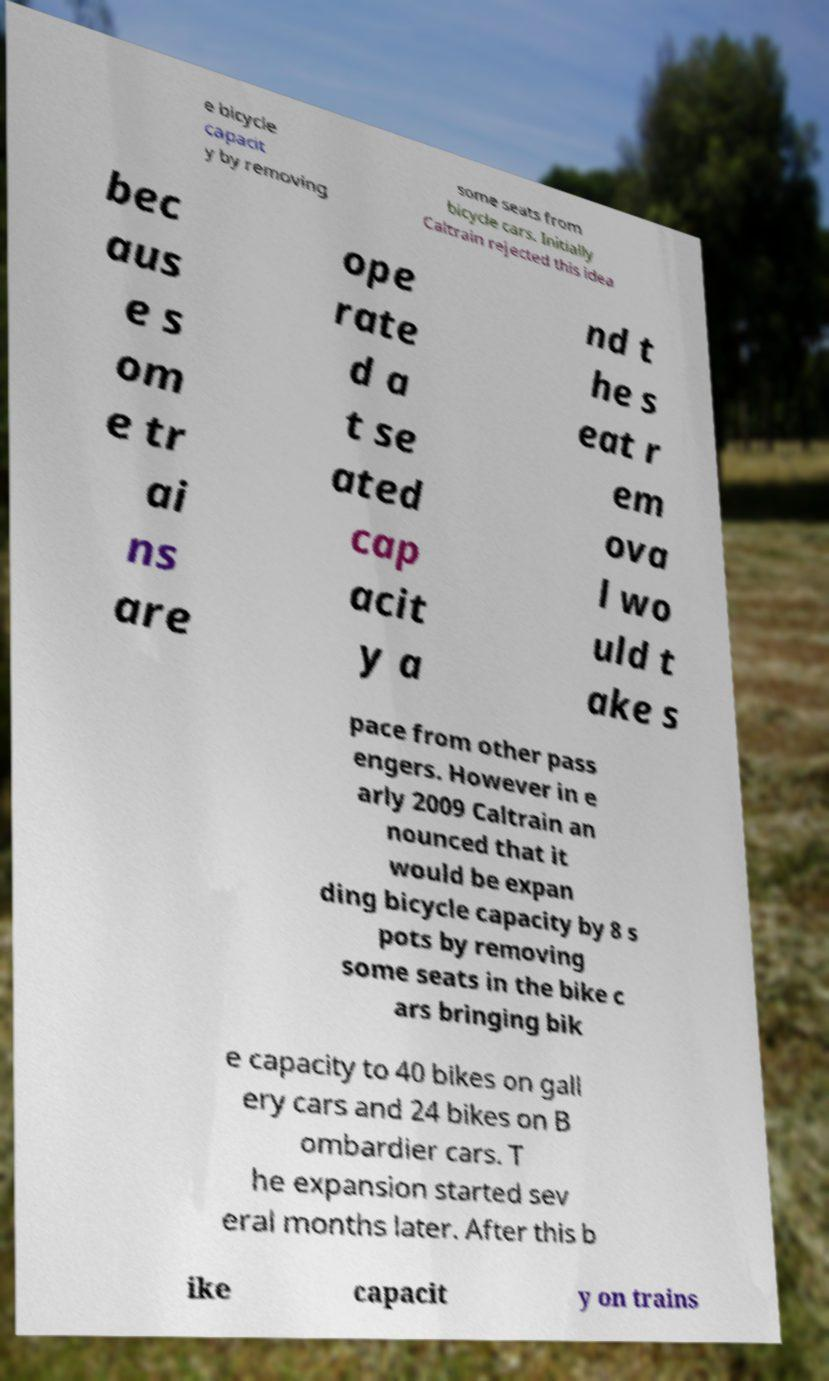Please identify and transcribe the text found in this image. e bicycle capacit y by removing some seats from bicycle cars. Initially Caltrain rejected this idea bec aus e s om e tr ai ns are ope rate d a t se ated cap acit y a nd t he s eat r em ova l wo uld t ake s pace from other pass engers. However in e arly 2009 Caltrain an nounced that it would be expan ding bicycle capacity by 8 s pots by removing some seats in the bike c ars bringing bik e capacity to 40 bikes on gall ery cars and 24 bikes on B ombardier cars. T he expansion started sev eral months later. After this b ike capacit y on trains 